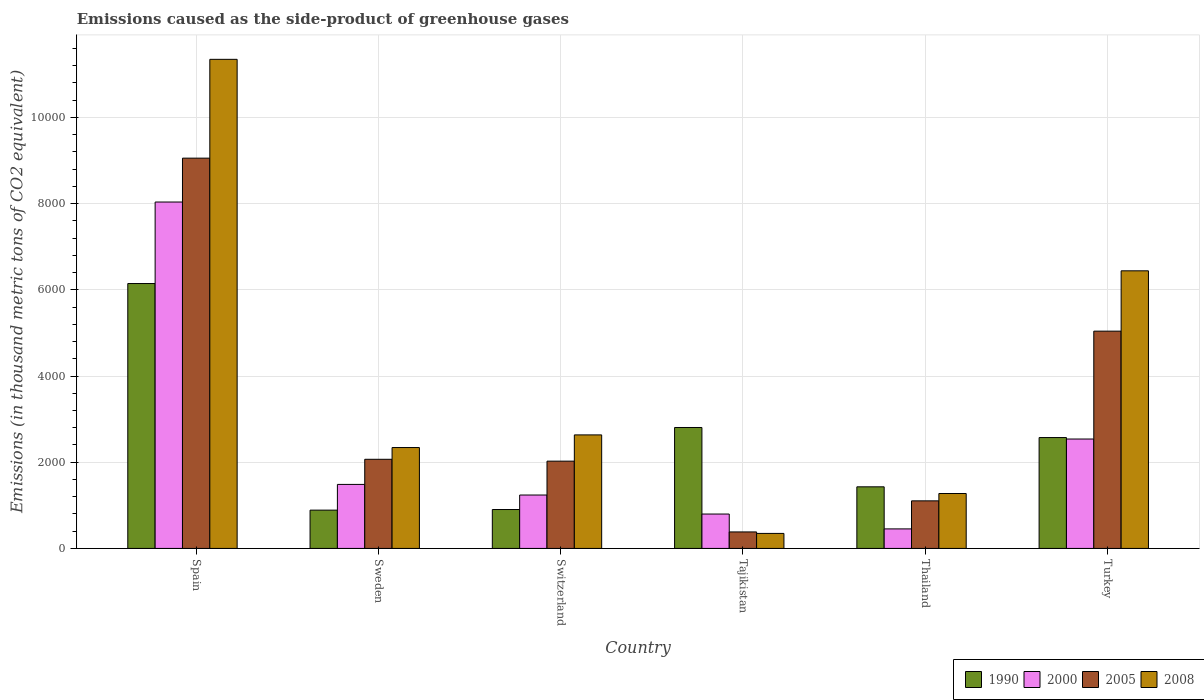Are the number of bars per tick equal to the number of legend labels?
Provide a short and direct response. Yes. Are the number of bars on each tick of the X-axis equal?
Your answer should be very brief. Yes. How many bars are there on the 3rd tick from the left?
Ensure brevity in your answer.  4. How many bars are there on the 4th tick from the right?
Offer a very short reply. 4. What is the label of the 1st group of bars from the left?
Give a very brief answer. Spain. What is the emissions caused as the side-product of greenhouse gases in 2000 in Tajikistan?
Provide a short and direct response. 798. Across all countries, what is the maximum emissions caused as the side-product of greenhouse gases in 2005?
Give a very brief answer. 9055.1. Across all countries, what is the minimum emissions caused as the side-product of greenhouse gases in 2008?
Keep it short and to the point. 348.3. In which country was the emissions caused as the side-product of greenhouse gases in 2008 minimum?
Ensure brevity in your answer.  Tajikistan. What is the total emissions caused as the side-product of greenhouse gases in 2008 in the graph?
Provide a succinct answer. 2.44e+04. What is the difference between the emissions caused as the side-product of greenhouse gases in 2008 in Thailand and that in Turkey?
Offer a terse response. -5166.5. What is the difference between the emissions caused as the side-product of greenhouse gases in 1990 in Switzerland and the emissions caused as the side-product of greenhouse gases in 2005 in Tajikistan?
Your answer should be compact. 519.6. What is the average emissions caused as the side-product of greenhouse gases in 2008 per country?
Provide a short and direct response. 4064.43. What is the difference between the emissions caused as the side-product of greenhouse gases of/in 2000 and emissions caused as the side-product of greenhouse gases of/in 2008 in Switzerland?
Provide a succinct answer. -1394.9. What is the ratio of the emissions caused as the side-product of greenhouse gases in 1990 in Sweden to that in Thailand?
Offer a terse response. 0.62. Is the emissions caused as the side-product of greenhouse gases in 2000 in Spain less than that in Tajikistan?
Ensure brevity in your answer.  No. Is the difference between the emissions caused as the side-product of greenhouse gases in 2000 in Tajikistan and Thailand greater than the difference between the emissions caused as the side-product of greenhouse gases in 2008 in Tajikistan and Thailand?
Ensure brevity in your answer.  Yes. What is the difference between the highest and the second highest emissions caused as the side-product of greenhouse gases in 2000?
Offer a terse response. -1053.2. What is the difference between the highest and the lowest emissions caused as the side-product of greenhouse gases in 2005?
Your answer should be very brief. 8672.1. In how many countries, is the emissions caused as the side-product of greenhouse gases in 2005 greater than the average emissions caused as the side-product of greenhouse gases in 2005 taken over all countries?
Make the answer very short. 2. Is the sum of the emissions caused as the side-product of greenhouse gases in 2008 in Switzerland and Tajikistan greater than the maximum emissions caused as the side-product of greenhouse gases in 2000 across all countries?
Keep it short and to the point. No. Is it the case that in every country, the sum of the emissions caused as the side-product of greenhouse gases in 2005 and emissions caused as the side-product of greenhouse gases in 1990 is greater than the sum of emissions caused as the side-product of greenhouse gases in 2008 and emissions caused as the side-product of greenhouse gases in 2000?
Your response must be concise. Yes. What does the 1st bar from the left in Tajikistan represents?
Give a very brief answer. 1990. What does the 4th bar from the right in Switzerland represents?
Your answer should be very brief. 1990. How many bars are there?
Your response must be concise. 24. Are all the bars in the graph horizontal?
Provide a short and direct response. No. Are the values on the major ticks of Y-axis written in scientific E-notation?
Offer a very short reply. No. Does the graph contain any zero values?
Provide a short and direct response. No. How many legend labels are there?
Your answer should be very brief. 4. How are the legend labels stacked?
Provide a short and direct response. Horizontal. What is the title of the graph?
Ensure brevity in your answer.  Emissions caused as the side-product of greenhouse gases. Does "1992" appear as one of the legend labels in the graph?
Your answer should be compact. No. What is the label or title of the X-axis?
Your response must be concise. Country. What is the label or title of the Y-axis?
Your answer should be compact. Emissions (in thousand metric tons of CO2 equivalent). What is the Emissions (in thousand metric tons of CO2 equivalent) of 1990 in Spain?
Offer a very short reply. 6146. What is the Emissions (in thousand metric tons of CO2 equivalent) in 2000 in Spain?
Make the answer very short. 8037.1. What is the Emissions (in thousand metric tons of CO2 equivalent) in 2005 in Spain?
Offer a terse response. 9055.1. What is the Emissions (in thousand metric tons of CO2 equivalent) in 2008 in Spain?
Give a very brief answer. 1.13e+04. What is the Emissions (in thousand metric tons of CO2 equivalent) in 1990 in Sweden?
Offer a terse response. 888.6. What is the Emissions (in thousand metric tons of CO2 equivalent) in 2000 in Sweden?
Ensure brevity in your answer.  1485.3. What is the Emissions (in thousand metric tons of CO2 equivalent) in 2005 in Sweden?
Your answer should be compact. 2068.4. What is the Emissions (in thousand metric tons of CO2 equivalent) in 2008 in Sweden?
Make the answer very short. 2340.9. What is the Emissions (in thousand metric tons of CO2 equivalent) of 1990 in Switzerland?
Provide a succinct answer. 902.6. What is the Emissions (in thousand metric tons of CO2 equivalent) in 2000 in Switzerland?
Keep it short and to the point. 1239.2. What is the Emissions (in thousand metric tons of CO2 equivalent) of 2005 in Switzerland?
Your answer should be compact. 2025. What is the Emissions (in thousand metric tons of CO2 equivalent) of 2008 in Switzerland?
Offer a very short reply. 2634.1. What is the Emissions (in thousand metric tons of CO2 equivalent) in 1990 in Tajikistan?
Keep it short and to the point. 2806.1. What is the Emissions (in thousand metric tons of CO2 equivalent) of 2000 in Tajikistan?
Your response must be concise. 798. What is the Emissions (in thousand metric tons of CO2 equivalent) in 2005 in Tajikistan?
Provide a succinct answer. 383. What is the Emissions (in thousand metric tons of CO2 equivalent) of 2008 in Tajikistan?
Offer a very short reply. 348.3. What is the Emissions (in thousand metric tons of CO2 equivalent) of 1990 in Thailand?
Provide a succinct answer. 1429.5. What is the Emissions (in thousand metric tons of CO2 equivalent) of 2000 in Thailand?
Give a very brief answer. 453.1. What is the Emissions (in thousand metric tons of CO2 equivalent) of 2005 in Thailand?
Provide a short and direct response. 1103.9. What is the Emissions (in thousand metric tons of CO2 equivalent) in 2008 in Thailand?
Make the answer very short. 1274.5. What is the Emissions (in thousand metric tons of CO2 equivalent) in 1990 in Turkey?
Keep it short and to the point. 2572.7. What is the Emissions (in thousand metric tons of CO2 equivalent) of 2000 in Turkey?
Your answer should be very brief. 2538.5. What is the Emissions (in thousand metric tons of CO2 equivalent) of 2005 in Turkey?
Your answer should be very brief. 5041.3. What is the Emissions (in thousand metric tons of CO2 equivalent) in 2008 in Turkey?
Provide a short and direct response. 6441. Across all countries, what is the maximum Emissions (in thousand metric tons of CO2 equivalent) of 1990?
Offer a very short reply. 6146. Across all countries, what is the maximum Emissions (in thousand metric tons of CO2 equivalent) of 2000?
Offer a terse response. 8037.1. Across all countries, what is the maximum Emissions (in thousand metric tons of CO2 equivalent) in 2005?
Give a very brief answer. 9055.1. Across all countries, what is the maximum Emissions (in thousand metric tons of CO2 equivalent) of 2008?
Provide a short and direct response. 1.13e+04. Across all countries, what is the minimum Emissions (in thousand metric tons of CO2 equivalent) of 1990?
Offer a terse response. 888.6. Across all countries, what is the minimum Emissions (in thousand metric tons of CO2 equivalent) of 2000?
Give a very brief answer. 453.1. Across all countries, what is the minimum Emissions (in thousand metric tons of CO2 equivalent) of 2005?
Ensure brevity in your answer.  383. Across all countries, what is the minimum Emissions (in thousand metric tons of CO2 equivalent) of 2008?
Offer a terse response. 348.3. What is the total Emissions (in thousand metric tons of CO2 equivalent) in 1990 in the graph?
Provide a succinct answer. 1.47e+04. What is the total Emissions (in thousand metric tons of CO2 equivalent) in 2000 in the graph?
Ensure brevity in your answer.  1.46e+04. What is the total Emissions (in thousand metric tons of CO2 equivalent) in 2005 in the graph?
Provide a short and direct response. 1.97e+04. What is the total Emissions (in thousand metric tons of CO2 equivalent) in 2008 in the graph?
Your answer should be compact. 2.44e+04. What is the difference between the Emissions (in thousand metric tons of CO2 equivalent) of 1990 in Spain and that in Sweden?
Give a very brief answer. 5257.4. What is the difference between the Emissions (in thousand metric tons of CO2 equivalent) of 2000 in Spain and that in Sweden?
Your response must be concise. 6551.8. What is the difference between the Emissions (in thousand metric tons of CO2 equivalent) of 2005 in Spain and that in Sweden?
Provide a succinct answer. 6986.7. What is the difference between the Emissions (in thousand metric tons of CO2 equivalent) of 2008 in Spain and that in Sweden?
Provide a succinct answer. 9006.9. What is the difference between the Emissions (in thousand metric tons of CO2 equivalent) in 1990 in Spain and that in Switzerland?
Keep it short and to the point. 5243.4. What is the difference between the Emissions (in thousand metric tons of CO2 equivalent) of 2000 in Spain and that in Switzerland?
Give a very brief answer. 6797.9. What is the difference between the Emissions (in thousand metric tons of CO2 equivalent) of 2005 in Spain and that in Switzerland?
Make the answer very short. 7030.1. What is the difference between the Emissions (in thousand metric tons of CO2 equivalent) of 2008 in Spain and that in Switzerland?
Make the answer very short. 8713.7. What is the difference between the Emissions (in thousand metric tons of CO2 equivalent) in 1990 in Spain and that in Tajikistan?
Your answer should be very brief. 3339.9. What is the difference between the Emissions (in thousand metric tons of CO2 equivalent) of 2000 in Spain and that in Tajikistan?
Offer a very short reply. 7239.1. What is the difference between the Emissions (in thousand metric tons of CO2 equivalent) in 2005 in Spain and that in Tajikistan?
Make the answer very short. 8672.1. What is the difference between the Emissions (in thousand metric tons of CO2 equivalent) in 2008 in Spain and that in Tajikistan?
Offer a very short reply. 1.10e+04. What is the difference between the Emissions (in thousand metric tons of CO2 equivalent) of 1990 in Spain and that in Thailand?
Offer a terse response. 4716.5. What is the difference between the Emissions (in thousand metric tons of CO2 equivalent) in 2000 in Spain and that in Thailand?
Offer a very short reply. 7584. What is the difference between the Emissions (in thousand metric tons of CO2 equivalent) of 2005 in Spain and that in Thailand?
Your answer should be very brief. 7951.2. What is the difference between the Emissions (in thousand metric tons of CO2 equivalent) of 2008 in Spain and that in Thailand?
Offer a very short reply. 1.01e+04. What is the difference between the Emissions (in thousand metric tons of CO2 equivalent) in 1990 in Spain and that in Turkey?
Provide a succinct answer. 3573.3. What is the difference between the Emissions (in thousand metric tons of CO2 equivalent) of 2000 in Spain and that in Turkey?
Your response must be concise. 5498.6. What is the difference between the Emissions (in thousand metric tons of CO2 equivalent) of 2005 in Spain and that in Turkey?
Offer a terse response. 4013.8. What is the difference between the Emissions (in thousand metric tons of CO2 equivalent) in 2008 in Spain and that in Turkey?
Provide a succinct answer. 4906.8. What is the difference between the Emissions (in thousand metric tons of CO2 equivalent) of 1990 in Sweden and that in Switzerland?
Offer a terse response. -14. What is the difference between the Emissions (in thousand metric tons of CO2 equivalent) in 2000 in Sweden and that in Switzerland?
Offer a terse response. 246.1. What is the difference between the Emissions (in thousand metric tons of CO2 equivalent) of 2005 in Sweden and that in Switzerland?
Offer a very short reply. 43.4. What is the difference between the Emissions (in thousand metric tons of CO2 equivalent) of 2008 in Sweden and that in Switzerland?
Provide a succinct answer. -293.2. What is the difference between the Emissions (in thousand metric tons of CO2 equivalent) in 1990 in Sweden and that in Tajikistan?
Offer a terse response. -1917.5. What is the difference between the Emissions (in thousand metric tons of CO2 equivalent) of 2000 in Sweden and that in Tajikistan?
Offer a very short reply. 687.3. What is the difference between the Emissions (in thousand metric tons of CO2 equivalent) of 2005 in Sweden and that in Tajikistan?
Your response must be concise. 1685.4. What is the difference between the Emissions (in thousand metric tons of CO2 equivalent) of 2008 in Sweden and that in Tajikistan?
Give a very brief answer. 1992.6. What is the difference between the Emissions (in thousand metric tons of CO2 equivalent) in 1990 in Sweden and that in Thailand?
Offer a terse response. -540.9. What is the difference between the Emissions (in thousand metric tons of CO2 equivalent) in 2000 in Sweden and that in Thailand?
Offer a terse response. 1032.2. What is the difference between the Emissions (in thousand metric tons of CO2 equivalent) of 2005 in Sweden and that in Thailand?
Give a very brief answer. 964.5. What is the difference between the Emissions (in thousand metric tons of CO2 equivalent) of 2008 in Sweden and that in Thailand?
Keep it short and to the point. 1066.4. What is the difference between the Emissions (in thousand metric tons of CO2 equivalent) in 1990 in Sweden and that in Turkey?
Ensure brevity in your answer.  -1684.1. What is the difference between the Emissions (in thousand metric tons of CO2 equivalent) of 2000 in Sweden and that in Turkey?
Offer a very short reply. -1053.2. What is the difference between the Emissions (in thousand metric tons of CO2 equivalent) of 2005 in Sweden and that in Turkey?
Give a very brief answer. -2972.9. What is the difference between the Emissions (in thousand metric tons of CO2 equivalent) in 2008 in Sweden and that in Turkey?
Your answer should be very brief. -4100.1. What is the difference between the Emissions (in thousand metric tons of CO2 equivalent) in 1990 in Switzerland and that in Tajikistan?
Provide a succinct answer. -1903.5. What is the difference between the Emissions (in thousand metric tons of CO2 equivalent) in 2000 in Switzerland and that in Tajikistan?
Provide a short and direct response. 441.2. What is the difference between the Emissions (in thousand metric tons of CO2 equivalent) in 2005 in Switzerland and that in Tajikistan?
Your answer should be very brief. 1642. What is the difference between the Emissions (in thousand metric tons of CO2 equivalent) of 2008 in Switzerland and that in Tajikistan?
Keep it short and to the point. 2285.8. What is the difference between the Emissions (in thousand metric tons of CO2 equivalent) of 1990 in Switzerland and that in Thailand?
Keep it short and to the point. -526.9. What is the difference between the Emissions (in thousand metric tons of CO2 equivalent) of 2000 in Switzerland and that in Thailand?
Make the answer very short. 786.1. What is the difference between the Emissions (in thousand metric tons of CO2 equivalent) in 2005 in Switzerland and that in Thailand?
Provide a succinct answer. 921.1. What is the difference between the Emissions (in thousand metric tons of CO2 equivalent) of 2008 in Switzerland and that in Thailand?
Ensure brevity in your answer.  1359.6. What is the difference between the Emissions (in thousand metric tons of CO2 equivalent) of 1990 in Switzerland and that in Turkey?
Give a very brief answer. -1670.1. What is the difference between the Emissions (in thousand metric tons of CO2 equivalent) in 2000 in Switzerland and that in Turkey?
Provide a short and direct response. -1299.3. What is the difference between the Emissions (in thousand metric tons of CO2 equivalent) of 2005 in Switzerland and that in Turkey?
Provide a succinct answer. -3016.3. What is the difference between the Emissions (in thousand metric tons of CO2 equivalent) in 2008 in Switzerland and that in Turkey?
Your answer should be compact. -3806.9. What is the difference between the Emissions (in thousand metric tons of CO2 equivalent) of 1990 in Tajikistan and that in Thailand?
Your answer should be very brief. 1376.6. What is the difference between the Emissions (in thousand metric tons of CO2 equivalent) in 2000 in Tajikistan and that in Thailand?
Your answer should be very brief. 344.9. What is the difference between the Emissions (in thousand metric tons of CO2 equivalent) in 2005 in Tajikistan and that in Thailand?
Ensure brevity in your answer.  -720.9. What is the difference between the Emissions (in thousand metric tons of CO2 equivalent) of 2008 in Tajikistan and that in Thailand?
Provide a short and direct response. -926.2. What is the difference between the Emissions (in thousand metric tons of CO2 equivalent) in 1990 in Tajikistan and that in Turkey?
Offer a terse response. 233.4. What is the difference between the Emissions (in thousand metric tons of CO2 equivalent) in 2000 in Tajikistan and that in Turkey?
Offer a terse response. -1740.5. What is the difference between the Emissions (in thousand metric tons of CO2 equivalent) in 2005 in Tajikistan and that in Turkey?
Make the answer very short. -4658.3. What is the difference between the Emissions (in thousand metric tons of CO2 equivalent) in 2008 in Tajikistan and that in Turkey?
Make the answer very short. -6092.7. What is the difference between the Emissions (in thousand metric tons of CO2 equivalent) in 1990 in Thailand and that in Turkey?
Your answer should be compact. -1143.2. What is the difference between the Emissions (in thousand metric tons of CO2 equivalent) of 2000 in Thailand and that in Turkey?
Your response must be concise. -2085.4. What is the difference between the Emissions (in thousand metric tons of CO2 equivalent) in 2005 in Thailand and that in Turkey?
Provide a succinct answer. -3937.4. What is the difference between the Emissions (in thousand metric tons of CO2 equivalent) of 2008 in Thailand and that in Turkey?
Provide a succinct answer. -5166.5. What is the difference between the Emissions (in thousand metric tons of CO2 equivalent) in 1990 in Spain and the Emissions (in thousand metric tons of CO2 equivalent) in 2000 in Sweden?
Your answer should be very brief. 4660.7. What is the difference between the Emissions (in thousand metric tons of CO2 equivalent) in 1990 in Spain and the Emissions (in thousand metric tons of CO2 equivalent) in 2005 in Sweden?
Make the answer very short. 4077.6. What is the difference between the Emissions (in thousand metric tons of CO2 equivalent) of 1990 in Spain and the Emissions (in thousand metric tons of CO2 equivalent) of 2008 in Sweden?
Make the answer very short. 3805.1. What is the difference between the Emissions (in thousand metric tons of CO2 equivalent) of 2000 in Spain and the Emissions (in thousand metric tons of CO2 equivalent) of 2005 in Sweden?
Provide a succinct answer. 5968.7. What is the difference between the Emissions (in thousand metric tons of CO2 equivalent) of 2000 in Spain and the Emissions (in thousand metric tons of CO2 equivalent) of 2008 in Sweden?
Provide a succinct answer. 5696.2. What is the difference between the Emissions (in thousand metric tons of CO2 equivalent) in 2005 in Spain and the Emissions (in thousand metric tons of CO2 equivalent) in 2008 in Sweden?
Ensure brevity in your answer.  6714.2. What is the difference between the Emissions (in thousand metric tons of CO2 equivalent) of 1990 in Spain and the Emissions (in thousand metric tons of CO2 equivalent) of 2000 in Switzerland?
Ensure brevity in your answer.  4906.8. What is the difference between the Emissions (in thousand metric tons of CO2 equivalent) in 1990 in Spain and the Emissions (in thousand metric tons of CO2 equivalent) in 2005 in Switzerland?
Keep it short and to the point. 4121. What is the difference between the Emissions (in thousand metric tons of CO2 equivalent) of 1990 in Spain and the Emissions (in thousand metric tons of CO2 equivalent) of 2008 in Switzerland?
Your answer should be very brief. 3511.9. What is the difference between the Emissions (in thousand metric tons of CO2 equivalent) in 2000 in Spain and the Emissions (in thousand metric tons of CO2 equivalent) in 2005 in Switzerland?
Give a very brief answer. 6012.1. What is the difference between the Emissions (in thousand metric tons of CO2 equivalent) in 2000 in Spain and the Emissions (in thousand metric tons of CO2 equivalent) in 2008 in Switzerland?
Your answer should be very brief. 5403. What is the difference between the Emissions (in thousand metric tons of CO2 equivalent) of 2005 in Spain and the Emissions (in thousand metric tons of CO2 equivalent) of 2008 in Switzerland?
Provide a short and direct response. 6421. What is the difference between the Emissions (in thousand metric tons of CO2 equivalent) in 1990 in Spain and the Emissions (in thousand metric tons of CO2 equivalent) in 2000 in Tajikistan?
Ensure brevity in your answer.  5348. What is the difference between the Emissions (in thousand metric tons of CO2 equivalent) in 1990 in Spain and the Emissions (in thousand metric tons of CO2 equivalent) in 2005 in Tajikistan?
Your answer should be compact. 5763. What is the difference between the Emissions (in thousand metric tons of CO2 equivalent) of 1990 in Spain and the Emissions (in thousand metric tons of CO2 equivalent) of 2008 in Tajikistan?
Offer a terse response. 5797.7. What is the difference between the Emissions (in thousand metric tons of CO2 equivalent) of 2000 in Spain and the Emissions (in thousand metric tons of CO2 equivalent) of 2005 in Tajikistan?
Ensure brevity in your answer.  7654.1. What is the difference between the Emissions (in thousand metric tons of CO2 equivalent) of 2000 in Spain and the Emissions (in thousand metric tons of CO2 equivalent) of 2008 in Tajikistan?
Your response must be concise. 7688.8. What is the difference between the Emissions (in thousand metric tons of CO2 equivalent) in 2005 in Spain and the Emissions (in thousand metric tons of CO2 equivalent) in 2008 in Tajikistan?
Give a very brief answer. 8706.8. What is the difference between the Emissions (in thousand metric tons of CO2 equivalent) of 1990 in Spain and the Emissions (in thousand metric tons of CO2 equivalent) of 2000 in Thailand?
Keep it short and to the point. 5692.9. What is the difference between the Emissions (in thousand metric tons of CO2 equivalent) in 1990 in Spain and the Emissions (in thousand metric tons of CO2 equivalent) in 2005 in Thailand?
Provide a succinct answer. 5042.1. What is the difference between the Emissions (in thousand metric tons of CO2 equivalent) in 1990 in Spain and the Emissions (in thousand metric tons of CO2 equivalent) in 2008 in Thailand?
Keep it short and to the point. 4871.5. What is the difference between the Emissions (in thousand metric tons of CO2 equivalent) of 2000 in Spain and the Emissions (in thousand metric tons of CO2 equivalent) of 2005 in Thailand?
Your response must be concise. 6933.2. What is the difference between the Emissions (in thousand metric tons of CO2 equivalent) in 2000 in Spain and the Emissions (in thousand metric tons of CO2 equivalent) in 2008 in Thailand?
Offer a very short reply. 6762.6. What is the difference between the Emissions (in thousand metric tons of CO2 equivalent) in 2005 in Spain and the Emissions (in thousand metric tons of CO2 equivalent) in 2008 in Thailand?
Offer a terse response. 7780.6. What is the difference between the Emissions (in thousand metric tons of CO2 equivalent) of 1990 in Spain and the Emissions (in thousand metric tons of CO2 equivalent) of 2000 in Turkey?
Your answer should be compact. 3607.5. What is the difference between the Emissions (in thousand metric tons of CO2 equivalent) in 1990 in Spain and the Emissions (in thousand metric tons of CO2 equivalent) in 2005 in Turkey?
Ensure brevity in your answer.  1104.7. What is the difference between the Emissions (in thousand metric tons of CO2 equivalent) of 1990 in Spain and the Emissions (in thousand metric tons of CO2 equivalent) of 2008 in Turkey?
Keep it short and to the point. -295. What is the difference between the Emissions (in thousand metric tons of CO2 equivalent) in 2000 in Spain and the Emissions (in thousand metric tons of CO2 equivalent) in 2005 in Turkey?
Offer a very short reply. 2995.8. What is the difference between the Emissions (in thousand metric tons of CO2 equivalent) of 2000 in Spain and the Emissions (in thousand metric tons of CO2 equivalent) of 2008 in Turkey?
Ensure brevity in your answer.  1596.1. What is the difference between the Emissions (in thousand metric tons of CO2 equivalent) in 2005 in Spain and the Emissions (in thousand metric tons of CO2 equivalent) in 2008 in Turkey?
Your answer should be compact. 2614.1. What is the difference between the Emissions (in thousand metric tons of CO2 equivalent) in 1990 in Sweden and the Emissions (in thousand metric tons of CO2 equivalent) in 2000 in Switzerland?
Your answer should be very brief. -350.6. What is the difference between the Emissions (in thousand metric tons of CO2 equivalent) of 1990 in Sweden and the Emissions (in thousand metric tons of CO2 equivalent) of 2005 in Switzerland?
Your answer should be very brief. -1136.4. What is the difference between the Emissions (in thousand metric tons of CO2 equivalent) in 1990 in Sweden and the Emissions (in thousand metric tons of CO2 equivalent) in 2008 in Switzerland?
Ensure brevity in your answer.  -1745.5. What is the difference between the Emissions (in thousand metric tons of CO2 equivalent) in 2000 in Sweden and the Emissions (in thousand metric tons of CO2 equivalent) in 2005 in Switzerland?
Ensure brevity in your answer.  -539.7. What is the difference between the Emissions (in thousand metric tons of CO2 equivalent) of 2000 in Sweden and the Emissions (in thousand metric tons of CO2 equivalent) of 2008 in Switzerland?
Offer a terse response. -1148.8. What is the difference between the Emissions (in thousand metric tons of CO2 equivalent) of 2005 in Sweden and the Emissions (in thousand metric tons of CO2 equivalent) of 2008 in Switzerland?
Ensure brevity in your answer.  -565.7. What is the difference between the Emissions (in thousand metric tons of CO2 equivalent) in 1990 in Sweden and the Emissions (in thousand metric tons of CO2 equivalent) in 2000 in Tajikistan?
Your answer should be very brief. 90.6. What is the difference between the Emissions (in thousand metric tons of CO2 equivalent) in 1990 in Sweden and the Emissions (in thousand metric tons of CO2 equivalent) in 2005 in Tajikistan?
Keep it short and to the point. 505.6. What is the difference between the Emissions (in thousand metric tons of CO2 equivalent) in 1990 in Sweden and the Emissions (in thousand metric tons of CO2 equivalent) in 2008 in Tajikistan?
Give a very brief answer. 540.3. What is the difference between the Emissions (in thousand metric tons of CO2 equivalent) of 2000 in Sweden and the Emissions (in thousand metric tons of CO2 equivalent) of 2005 in Tajikistan?
Keep it short and to the point. 1102.3. What is the difference between the Emissions (in thousand metric tons of CO2 equivalent) in 2000 in Sweden and the Emissions (in thousand metric tons of CO2 equivalent) in 2008 in Tajikistan?
Your answer should be very brief. 1137. What is the difference between the Emissions (in thousand metric tons of CO2 equivalent) of 2005 in Sweden and the Emissions (in thousand metric tons of CO2 equivalent) of 2008 in Tajikistan?
Your answer should be very brief. 1720.1. What is the difference between the Emissions (in thousand metric tons of CO2 equivalent) in 1990 in Sweden and the Emissions (in thousand metric tons of CO2 equivalent) in 2000 in Thailand?
Your response must be concise. 435.5. What is the difference between the Emissions (in thousand metric tons of CO2 equivalent) in 1990 in Sweden and the Emissions (in thousand metric tons of CO2 equivalent) in 2005 in Thailand?
Keep it short and to the point. -215.3. What is the difference between the Emissions (in thousand metric tons of CO2 equivalent) of 1990 in Sweden and the Emissions (in thousand metric tons of CO2 equivalent) of 2008 in Thailand?
Provide a short and direct response. -385.9. What is the difference between the Emissions (in thousand metric tons of CO2 equivalent) of 2000 in Sweden and the Emissions (in thousand metric tons of CO2 equivalent) of 2005 in Thailand?
Give a very brief answer. 381.4. What is the difference between the Emissions (in thousand metric tons of CO2 equivalent) of 2000 in Sweden and the Emissions (in thousand metric tons of CO2 equivalent) of 2008 in Thailand?
Your answer should be compact. 210.8. What is the difference between the Emissions (in thousand metric tons of CO2 equivalent) of 2005 in Sweden and the Emissions (in thousand metric tons of CO2 equivalent) of 2008 in Thailand?
Your answer should be compact. 793.9. What is the difference between the Emissions (in thousand metric tons of CO2 equivalent) in 1990 in Sweden and the Emissions (in thousand metric tons of CO2 equivalent) in 2000 in Turkey?
Offer a very short reply. -1649.9. What is the difference between the Emissions (in thousand metric tons of CO2 equivalent) in 1990 in Sweden and the Emissions (in thousand metric tons of CO2 equivalent) in 2005 in Turkey?
Offer a terse response. -4152.7. What is the difference between the Emissions (in thousand metric tons of CO2 equivalent) in 1990 in Sweden and the Emissions (in thousand metric tons of CO2 equivalent) in 2008 in Turkey?
Provide a succinct answer. -5552.4. What is the difference between the Emissions (in thousand metric tons of CO2 equivalent) in 2000 in Sweden and the Emissions (in thousand metric tons of CO2 equivalent) in 2005 in Turkey?
Make the answer very short. -3556. What is the difference between the Emissions (in thousand metric tons of CO2 equivalent) of 2000 in Sweden and the Emissions (in thousand metric tons of CO2 equivalent) of 2008 in Turkey?
Give a very brief answer. -4955.7. What is the difference between the Emissions (in thousand metric tons of CO2 equivalent) in 2005 in Sweden and the Emissions (in thousand metric tons of CO2 equivalent) in 2008 in Turkey?
Your response must be concise. -4372.6. What is the difference between the Emissions (in thousand metric tons of CO2 equivalent) of 1990 in Switzerland and the Emissions (in thousand metric tons of CO2 equivalent) of 2000 in Tajikistan?
Give a very brief answer. 104.6. What is the difference between the Emissions (in thousand metric tons of CO2 equivalent) of 1990 in Switzerland and the Emissions (in thousand metric tons of CO2 equivalent) of 2005 in Tajikistan?
Ensure brevity in your answer.  519.6. What is the difference between the Emissions (in thousand metric tons of CO2 equivalent) of 1990 in Switzerland and the Emissions (in thousand metric tons of CO2 equivalent) of 2008 in Tajikistan?
Provide a short and direct response. 554.3. What is the difference between the Emissions (in thousand metric tons of CO2 equivalent) in 2000 in Switzerland and the Emissions (in thousand metric tons of CO2 equivalent) in 2005 in Tajikistan?
Your answer should be very brief. 856.2. What is the difference between the Emissions (in thousand metric tons of CO2 equivalent) of 2000 in Switzerland and the Emissions (in thousand metric tons of CO2 equivalent) of 2008 in Tajikistan?
Your answer should be compact. 890.9. What is the difference between the Emissions (in thousand metric tons of CO2 equivalent) of 2005 in Switzerland and the Emissions (in thousand metric tons of CO2 equivalent) of 2008 in Tajikistan?
Your response must be concise. 1676.7. What is the difference between the Emissions (in thousand metric tons of CO2 equivalent) of 1990 in Switzerland and the Emissions (in thousand metric tons of CO2 equivalent) of 2000 in Thailand?
Offer a terse response. 449.5. What is the difference between the Emissions (in thousand metric tons of CO2 equivalent) of 1990 in Switzerland and the Emissions (in thousand metric tons of CO2 equivalent) of 2005 in Thailand?
Provide a succinct answer. -201.3. What is the difference between the Emissions (in thousand metric tons of CO2 equivalent) of 1990 in Switzerland and the Emissions (in thousand metric tons of CO2 equivalent) of 2008 in Thailand?
Provide a short and direct response. -371.9. What is the difference between the Emissions (in thousand metric tons of CO2 equivalent) of 2000 in Switzerland and the Emissions (in thousand metric tons of CO2 equivalent) of 2005 in Thailand?
Provide a succinct answer. 135.3. What is the difference between the Emissions (in thousand metric tons of CO2 equivalent) in 2000 in Switzerland and the Emissions (in thousand metric tons of CO2 equivalent) in 2008 in Thailand?
Your response must be concise. -35.3. What is the difference between the Emissions (in thousand metric tons of CO2 equivalent) of 2005 in Switzerland and the Emissions (in thousand metric tons of CO2 equivalent) of 2008 in Thailand?
Provide a short and direct response. 750.5. What is the difference between the Emissions (in thousand metric tons of CO2 equivalent) in 1990 in Switzerland and the Emissions (in thousand metric tons of CO2 equivalent) in 2000 in Turkey?
Keep it short and to the point. -1635.9. What is the difference between the Emissions (in thousand metric tons of CO2 equivalent) in 1990 in Switzerland and the Emissions (in thousand metric tons of CO2 equivalent) in 2005 in Turkey?
Ensure brevity in your answer.  -4138.7. What is the difference between the Emissions (in thousand metric tons of CO2 equivalent) of 1990 in Switzerland and the Emissions (in thousand metric tons of CO2 equivalent) of 2008 in Turkey?
Provide a short and direct response. -5538.4. What is the difference between the Emissions (in thousand metric tons of CO2 equivalent) of 2000 in Switzerland and the Emissions (in thousand metric tons of CO2 equivalent) of 2005 in Turkey?
Offer a terse response. -3802.1. What is the difference between the Emissions (in thousand metric tons of CO2 equivalent) of 2000 in Switzerland and the Emissions (in thousand metric tons of CO2 equivalent) of 2008 in Turkey?
Provide a succinct answer. -5201.8. What is the difference between the Emissions (in thousand metric tons of CO2 equivalent) of 2005 in Switzerland and the Emissions (in thousand metric tons of CO2 equivalent) of 2008 in Turkey?
Your answer should be very brief. -4416. What is the difference between the Emissions (in thousand metric tons of CO2 equivalent) in 1990 in Tajikistan and the Emissions (in thousand metric tons of CO2 equivalent) in 2000 in Thailand?
Offer a very short reply. 2353. What is the difference between the Emissions (in thousand metric tons of CO2 equivalent) in 1990 in Tajikistan and the Emissions (in thousand metric tons of CO2 equivalent) in 2005 in Thailand?
Ensure brevity in your answer.  1702.2. What is the difference between the Emissions (in thousand metric tons of CO2 equivalent) of 1990 in Tajikistan and the Emissions (in thousand metric tons of CO2 equivalent) of 2008 in Thailand?
Make the answer very short. 1531.6. What is the difference between the Emissions (in thousand metric tons of CO2 equivalent) of 2000 in Tajikistan and the Emissions (in thousand metric tons of CO2 equivalent) of 2005 in Thailand?
Provide a short and direct response. -305.9. What is the difference between the Emissions (in thousand metric tons of CO2 equivalent) in 2000 in Tajikistan and the Emissions (in thousand metric tons of CO2 equivalent) in 2008 in Thailand?
Your response must be concise. -476.5. What is the difference between the Emissions (in thousand metric tons of CO2 equivalent) of 2005 in Tajikistan and the Emissions (in thousand metric tons of CO2 equivalent) of 2008 in Thailand?
Offer a terse response. -891.5. What is the difference between the Emissions (in thousand metric tons of CO2 equivalent) of 1990 in Tajikistan and the Emissions (in thousand metric tons of CO2 equivalent) of 2000 in Turkey?
Provide a short and direct response. 267.6. What is the difference between the Emissions (in thousand metric tons of CO2 equivalent) in 1990 in Tajikistan and the Emissions (in thousand metric tons of CO2 equivalent) in 2005 in Turkey?
Provide a short and direct response. -2235.2. What is the difference between the Emissions (in thousand metric tons of CO2 equivalent) of 1990 in Tajikistan and the Emissions (in thousand metric tons of CO2 equivalent) of 2008 in Turkey?
Ensure brevity in your answer.  -3634.9. What is the difference between the Emissions (in thousand metric tons of CO2 equivalent) of 2000 in Tajikistan and the Emissions (in thousand metric tons of CO2 equivalent) of 2005 in Turkey?
Give a very brief answer. -4243.3. What is the difference between the Emissions (in thousand metric tons of CO2 equivalent) in 2000 in Tajikistan and the Emissions (in thousand metric tons of CO2 equivalent) in 2008 in Turkey?
Your answer should be very brief. -5643. What is the difference between the Emissions (in thousand metric tons of CO2 equivalent) of 2005 in Tajikistan and the Emissions (in thousand metric tons of CO2 equivalent) of 2008 in Turkey?
Give a very brief answer. -6058. What is the difference between the Emissions (in thousand metric tons of CO2 equivalent) in 1990 in Thailand and the Emissions (in thousand metric tons of CO2 equivalent) in 2000 in Turkey?
Your response must be concise. -1109. What is the difference between the Emissions (in thousand metric tons of CO2 equivalent) of 1990 in Thailand and the Emissions (in thousand metric tons of CO2 equivalent) of 2005 in Turkey?
Offer a terse response. -3611.8. What is the difference between the Emissions (in thousand metric tons of CO2 equivalent) of 1990 in Thailand and the Emissions (in thousand metric tons of CO2 equivalent) of 2008 in Turkey?
Provide a short and direct response. -5011.5. What is the difference between the Emissions (in thousand metric tons of CO2 equivalent) of 2000 in Thailand and the Emissions (in thousand metric tons of CO2 equivalent) of 2005 in Turkey?
Offer a very short reply. -4588.2. What is the difference between the Emissions (in thousand metric tons of CO2 equivalent) of 2000 in Thailand and the Emissions (in thousand metric tons of CO2 equivalent) of 2008 in Turkey?
Provide a short and direct response. -5987.9. What is the difference between the Emissions (in thousand metric tons of CO2 equivalent) in 2005 in Thailand and the Emissions (in thousand metric tons of CO2 equivalent) in 2008 in Turkey?
Your answer should be compact. -5337.1. What is the average Emissions (in thousand metric tons of CO2 equivalent) of 1990 per country?
Give a very brief answer. 2457.58. What is the average Emissions (in thousand metric tons of CO2 equivalent) of 2000 per country?
Provide a succinct answer. 2425.2. What is the average Emissions (in thousand metric tons of CO2 equivalent) of 2005 per country?
Ensure brevity in your answer.  3279.45. What is the average Emissions (in thousand metric tons of CO2 equivalent) in 2008 per country?
Your answer should be compact. 4064.43. What is the difference between the Emissions (in thousand metric tons of CO2 equivalent) of 1990 and Emissions (in thousand metric tons of CO2 equivalent) of 2000 in Spain?
Your answer should be very brief. -1891.1. What is the difference between the Emissions (in thousand metric tons of CO2 equivalent) in 1990 and Emissions (in thousand metric tons of CO2 equivalent) in 2005 in Spain?
Your answer should be compact. -2909.1. What is the difference between the Emissions (in thousand metric tons of CO2 equivalent) of 1990 and Emissions (in thousand metric tons of CO2 equivalent) of 2008 in Spain?
Provide a succinct answer. -5201.8. What is the difference between the Emissions (in thousand metric tons of CO2 equivalent) in 2000 and Emissions (in thousand metric tons of CO2 equivalent) in 2005 in Spain?
Provide a succinct answer. -1018. What is the difference between the Emissions (in thousand metric tons of CO2 equivalent) in 2000 and Emissions (in thousand metric tons of CO2 equivalent) in 2008 in Spain?
Offer a terse response. -3310.7. What is the difference between the Emissions (in thousand metric tons of CO2 equivalent) in 2005 and Emissions (in thousand metric tons of CO2 equivalent) in 2008 in Spain?
Give a very brief answer. -2292.7. What is the difference between the Emissions (in thousand metric tons of CO2 equivalent) in 1990 and Emissions (in thousand metric tons of CO2 equivalent) in 2000 in Sweden?
Provide a succinct answer. -596.7. What is the difference between the Emissions (in thousand metric tons of CO2 equivalent) of 1990 and Emissions (in thousand metric tons of CO2 equivalent) of 2005 in Sweden?
Offer a terse response. -1179.8. What is the difference between the Emissions (in thousand metric tons of CO2 equivalent) in 1990 and Emissions (in thousand metric tons of CO2 equivalent) in 2008 in Sweden?
Your response must be concise. -1452.3. What is the difference between the Emissions (in thousand metric tons of CO2 equivalent) in 2000 and Emissions (in thousand metric tons of CO2 equivalent) in 2005 in Sweden?
Make the answer very short. -583.1. What is the difference between the Emissions (in thousand metric tons of CO2 equivalent) in 2000 and Emissions (in thousand metric tons of CO2 equivalent) in 2008 in Sweden?
Offer a terse response. -855.6. What is the difference between the Emissions (in thousand metric tons of CO2 equivalent) in 2005 and Emissions (in thousand metric tons of CO2 equivalent) in 2008 in Sweden?
Your answer should be compact. -272.5. What is the difference between the Emissions (in thousand metric tons of CO2 equivalent) of 1990 and Emissions (in thousand metric tons of CO2 equivalent) of 2000 in Switzerland?
Your response must be concise. -336.6. What is the difference between the Emissions (in thousand metric tons of CO2 equivalent) in 1990 and Emissions (in thousand metric tons of CO2 equivalent) in 2005 in Switzerland?
Ensure brevity in your answer.  -1122.4. What is the difference between the Emissions (in thousand metric tons of CO2 equivalent) of 1990 and Emissions (in thousand metric tons of CO2 equivalent) of 2008 in Switzerland?
Keep it short and to the point. -1731.5. What is the difference between the Emissions (in thousand metric tons of CO2 equivalent) of 2000 and Emissions (in thousand metric tons of CO2 equivalent) of 2005 in Switzerland?
Provide a short and direct response. -785.8. What is the difference between the Emissions (in thousand metric tons of CO2 equivalent) in 2000 and Emissions (in thousand metric tons of CO2 equivalent) in 2008 in Switzerland?
Make the answer very short. -1394.9. What is the difference between the Emissions (in thousand metric tons of CO2 equivalent) of 2005 and Emissions (in thousand metric tons of CO2 equivalent) of 2008 in Switzerland?
Your answer should be very brief. -609.1. What is the difference between the Emissions (in thousand metric tons of CO2 equivalent) in 1990 and Emissions (in thousand metric tons of CO2 equivalent) in 2000 in Tajikistan?
Keep it short and to the point. 2008.1. What is the difference between the Emissions (in thousand metric tons of CO2 equivalent) in 1990 and Emissions (in thousand metric tons of CO2 equivalent) in 2005 in Tajikistan?
Provide a short and direct response. 2423.1. What is the difference between the Emissions (in thousand metric tons of CO2 equivalent) in 1990 and Emissions (in thousand metric tons of CO2 equivalent) in 2008 in Tajikistan?
Make the answer very short. 2457.8. What is the difference between the Emissions (in thousand metric tons of CO2 equivalent) in 2000 and Emissions (in thousand metric tons of CO2 equivalent) in 2005 in Tajikistan?
Provide a short and direct response. 415. What is the difference between the Emissions (in thousand metric tons of CO2 equivalent) in 2000 and Emissions (in thousand metric tons of CO2 equivalent) in 2008 in Tajikistan?
Keep it short and to the point. 449.7. What is the difference between the Emissions (in thousand metric tons of CO2 equivalent) in 2005 and Emissions (in thousand metric tons of CO2 equivalent) in 2008 in Tajikistan?
Your answer should be very brief. 34.7. What is the difference between the Emissions (in thousand metric tons of CO2 equivalent) in 1990 and Emissions (in thousand metric tons of CO2 equivalent) in 2000 in Thailand?
Offer a terse response. 976.4. What is the difference between the Emissions (in thousand metric tons of CO2 equivalent) in 1990 and Emissions (in thousand metric tons of CO2 equivalent) in 2005 in Thailand?
Offer a terse response. 325.6. What is the difference between the Emissions (in thousand metric tons of CO2 equivalent) of 1990 and Emissions (in thousand metric tons of CO2 equivalent) of 2008 in Thailand?
Your answer should be very brief. 155. What is the difference between the Emissions (in thousand metric tons of CO2 equivalent) in 2000 and Emissions (in thousand metric tons of CO2 equivalent) in 2005 in Thailand?
Your answer should be compact. -650.8. What is the difference between the Emissions (in thousand metric tons of CO2 equivalent) of 2000 and Emissions (in thousand metric tons of CO2 equivalent) of 2008 in Thailand?
Provide a short and direct response. -821.4. What is the difference between the Emissions (in thousand metric tons of CO2 equivalent) of 2005 and Emissions (in thousand metric tons of CO2 equivalent) of 2008 in Thailand?
Your response must be concise. -170.6. What is the difference between the Emissions (in thousand metric tons of CO2 equivalent) of 1990 and Emissions (in thousand metric tons of CO2 equivalent) of 2000 in Turkey?
Provide a short and direct response. 34.2. What is the difference between the Emissions (in thousand metric tons of CO2 equivalent) of 1990 and Emissions (in thousand metric tons of CO2 equivalent) of 2005 in Turkey?
Provide a succinct answer. -2468.6. What is the difference between the Emissions (in thousand metric tons of CO2 equivalent) in 1990 and Emissions (in thousand metric tons of CO2 equivalent) in 2008 in Turkey?
Ensure brevity in your answer.  -3868.3. What is the difference between the Emissions (in thousand metric tons of CO2 equivalent) of 2000 and Emissions (in thousand metric tons of CO2 equivalent) of 2005 in Turkey?
Keep it short and to the point. -2502.8. What is the difference between the Emissions (in thousand metric tons of CO2 equivalent) of 2000 and Emissions (in thousand metric tons of CO2 equivalent) of 2008 in Turkey?
Your answer should be compact. -3902.5. What is the difference between the Emissions (in thousand metric tons of CO2 equivalent) in 2005 and Emissions (in thousand metric tons of CO2 equivalent) in 2008 in Turkey?
Offer a terse response. -1399.7. What is the ratio of the Emissions (in thousand metric tons of CO2 equivalent) in 1990 in Spain to that in Sweden?
Make the answer very short. 6.92. What is the ratio of the Emissions (in thousand metric tons of CO2 equivalent) in 2000 in Spain to that in Sweden?
Make the answer very short. 5.41. What is the ratio of the Emissions (in thousand metric tons of CO2 equivalent) of 2005 in Spain to that in Sweden?
Your answer should be compact. 4.38. What is the ratio of the Emissions (in thousand metric tons of CO2 equivalent) in 2008 in Spain to that in Sweden?
Your answer should be very brief. 4.85. What is the ratio of the Emissions (in thousand metric tons of CO2 equivalent) in 1990 in Spain to that in Switzerland?
Your answer should be very brief. 6.81. What is the ratio of the Emissions (in thousand metric tons of CO2 equivalent) in 2000 in Spain to that in Switzerland?
Your response must be concise. 6.49. What is the ratio of the Emissions (in thousand metric tons of CO2 equivalent) of 2005 in Spain to that in Switzerland?
Keep it short and to the point. 4.47. What is the ratio of the Emissions (in thousand metric tons of CO2 equivalent) in 2008 in Spain to that in Switzerland?
Offer a very short reply. 4.31. What is the ratio of the Emissions (in thousand metric tons of CO2 equivalent) of 1990 in Spain to that in Tajikistan?
Your response must be concise. 2.19. What is the ratio of the Emissions (in thousand metric tons of CO2 equivalent) of 2000 in Spain to that in Tajikistan?
Offer a very short reply. 10.07. What is the ratio of the Emissions (in thousand metric tons of CO2 equivalent) in 2005 in Spain to that in Tajikistan?
Give a very brief answer. 23.64. What is the ratio of the Emissions (in thousand metric tons of CO2 equivalent) of 2008 in Spain to that in Tajikistan?
Provide a short and direct response. 32.58. What is the ratio of the Emissions (in thousand metric tons of CO2 equivalent) in 1990 in Spain to that in Thailand?
Your response must be concise. 4.3. What is the ratio of the Emissions (in thousand metric tons of CO2 equivalent) in 2000 in Spain to that in Thailand?
Provide a succinct answer. 17.74. What is the ratio of the Emissions (in thousand metric tons of CO2 equivalent) of 2005 in Spain to that in Thailand?
Your answer should be compact. 8.2. What is the ratio of the Emissions (in thousand metric tons of CO2 equivalent) of 2008 in Spain to that in Thailand?
Your answer should be compact. 8.9. What is the ratio of the Emissions (in thousand metric tons of CO2 equivalent) in 1990 in Spain to that in Turkey?
Your response must be concise. 2.39. What is the ratio of the Emissions (in thousand metric tons of CO2 equivalent) of 2000 in Spain to that in Turkey?
Provide a succinct answer. 3.17. What is the ratio of the Emissions (in thousand metric tons of CO2 equivalent) in 2005 in Spain to that in Turkey?
Your answer should be very brief. 1.8. What is the ratio of the Emissions (in thousand metric tons of CO2 equivalent) of 2008 in Spain to that in Turkey?
Your answer should be compact. 1.76. What is the ratio of the Emissions (in thousand metric tons of CO2 equivalent) of 1990 in Sweden to that in Switzerland?
Offer a very short reply. 0.98. What is the ratio of the Emissions (in thousand metric tons of CO2 equivalent) of 2000 in Sweden to that in Switzerland?
Your response must be concise. 1.2. What is the ratio of the Emissions (in thousand metric tons of CO2 equivalent) of 2005 in Sweden to that in Switzerland?
Provide a succinct answer. 1.02. What is the ratio of the Emissions (in thousand metric tons of CO2 equivalent) in 2008 in Sweden to that in Switzerland?
Your answer should be compact. 0.89. What is the ratio of the Emissions (in thousand metric tons of CO2 equivalent) of 1990 in Sweden to that in Tajikistan?
Your answer should be compact. 0.32. What is the ratio of the Emissions (in thousand metric tons of CO2 equivalent) of 2000 in Sweden to that in Tajikistan?
Your answer should be compact. 1.86. What is the ratio of the Emissions (in thousand metric tons of CO2 equivalent) of 2005 in Sweden to that in Tajikistan?
Ensure brevity in your answer.  5.4. What is the ratio of the Emissions (in thousand metric tons of CO2 equivalent) of 2008 in Sweden to that in Tajikistan?
Offer a terse response. 6.72. What is the ratio of the Emissions (in thousand metric tons of CO2 equivalent) of 1990 in Sweden to that in Thailand?
Your answer should be compact. 0.62. What is the ratio of the Emissions (in thousand metric tons of CO2 equivalent) of 2000 in Sweden to that in Thailand?
Offer a very short reply. 3.28. What is the ratio of the Emissions (in thousand metric tons of CO2 equivalent) of 2005 in Sweden to that in Thailand?
Offer a terse response. 1.87. What is the ratio of the Emissions (in thousand metric tons of CO2 equivalent) of 2008 in Sweden to that in Thailand?
Make the answer very short. 1.84. What is the ratio of the Emissions (in thousand metric tons of CO2 equivalent) in 1990 in Sweden to that in Turkey?
Give a very brief answer. 0.35. What is the ratio of the Emissions (in thousand metric tons of CO2 equivalent) in 2000 in Sweden to that in Turkey?
Give a very brief answer. 0.59. What is the ratio of the Emissions (in thousand metric tons of CO2 equivalent) of 2005 in Sweden to that in Turkey?
Your answer should be very brief. 0.41. What is the ratio of the Emissions (in thousand metric tons of CO2 equivalent) of 2008 in Sweden to that in Turkey?
Offer a terse response. 0.36. What is the ratio of the Emissions (in thousand metric tons of CO2 equivalent) of 1990 in Switzerland to that in Tajikistan?
Offer a very short reply. 0.32. What is the ratio of the Emissions (in thousand metric tons of CO2 equivalent) of 2000 in Switzerland to that in Tajikistan?
Provide a succinct answer. 1.55. What is the ratio of the Emissions (in thousand metric tons of CO2 equivalent) of 2005 in Switzerland to that in Tajikistan?
Ensure brevity in your answer.  5.29. What is the ratio of the Emissions (in thousand metric tons of CO2 equivalent) in 2008 in Switzerland to that in Tajikistan?
Offer a very short reply. 7.56. What is the ratio of the Emissions (in thousand metric tons of CO2 equivalent) of 1990 in Switzerland to that in Thailand?
Provide a succinct answer. 0.63. What is the ratio of the Emissions (in thousand metric tons of CO2 equivalent) of 2000 in Switzerland to that in Thailand?
Ensure brevity in your answer.  2.73. What is the ratio of the Emissions (in thousand metric tons of CO2 equivalent) of 2005 in Switzerland to that in Thailand?
Give a very brief answer. 1.83. What is the ratio of the Emissions (in thousand metric tons of CO2 equivalent) of 2008 in Switzerland to that in Thailand?
Keep it short and to the point. 2.07. What is the ratio of the Emissions (in thousand metric tons of CO2 equivalent) in 1990 in Switzerland to that in Turkey?
Your answer should be very brief. 0.35. What is the ratio of the Emissions (in thousand metric tons of CO2 equivalent) of 2000 in Switzerland to that in Turkey?
Provide a short and direct response. 0.49. What is the ratio of the Emissions (in thousand metric tons of CO2 equivalent) of 2005 in Switzerland to that in Turkey?
Give a very brief answer. 0.4. What is the ratio of the Emissions (in thousand metric tons of CO2 equivalent) in 2008 in Switzerland to that in Turkey?
Ensure brevity in your answer.  0.41. What is the ratio of the Emissions (in thousand metric tons of CO2 equivalent) of 1990 in Tajikistan to that in Thailand?
Offer a terse response. 1.96. What is the ratio of the Emissions (in thousand metric tons of CO2 equivalent) in 2000 in Tajikistan to that in Thailand?
Ensure brevity in your answer.  1.76. What is the ratio of the Emissions (in thousand metric tons of CO2 equivalent) in 2005 in Tajikistan to that in Thailand?
Offer a very short reply. 0.35. What is the ratio of the Emissions (in thousand metric tons of CO2 equivalent) in 2008 in Tajikistan to that in Thailand?
Your answer should be compact. 0.27. What is the ratio of the Emissions (in thousand metric tons of CO2 equivalent) in 1990 in Tajikistan to that in Turkey?
Keep it short and to the point. 1.09. What is the ratio of the Emissions (in thousand metric tons of CO2 equivalent) of 2000 in Tajikistan to that in Turkey?
Give a very brief answer. 0.31. What is the ratio of the Emissions (in thousand metric tons of CO2 equivalent) of 2005 in Tajikistan to that in Turkey?
Provide a succinct answer. 0.08. What is the ratio of the Emissions (in thousand metric tons of CO2 equivalent) in 2008 in Tajikistan to that in Turkey?
Provide a short and direct response. 0.05. What is the ratio of the Emissions (in thousand metric tons of CO2 equivalent) of 1990 in Thailand to that in Turkey?
Give a very brief answer. 0.56. What is the ratio of the Emissions (in thousand metric tons of CO2 equivalent) of 2000 in Thailand to that in Turkey?
Offer a terse response. 0.18. What is the ratio of the Emissions (in thousand metric tons of CO2 equivalent) of 2005 in Thailand to that in Turkey?
Ensure brevity in your answer.  0.22. What is the ratio of the Emissions (in thousand metric tons of CO2 equivalent) of 2008 in Thailand to that in Turkey?
Make the answer very short. 0.2. What is the difference between the highest and the second highest Emissions (in thousand metric tons of CO2 equivalent) in 1990?
Provide a short and direct response. 3339.9. What is the difference between the highest and the second highest Emissions (in thousand metric tons of CO2 equivalent) of 2000?
Your response must be concise. 5498.6. What is the difference between the highest and the second highest Emissions (in thousand metric tons of CO2 equivalent) in 2005?
Keep it short and to the point. 4013.8. What is the difference between the highest and the second highest Emissions (in thousand metric tons of CO2 equivalent) in 2008?
Offer a terse response. 4906.8. What is the difference between the highest and the lowest Emissions (in thousand metric tons of CO2 equivalent) of 1990?
Offer a very short reply. 5257.4. What is the difference between the highest and the lowest Emissions (in thousand metric tons of CO2 equivalent) of 2000?
Provide a short and direct response. 7584. What is the difference between the highest and the lowest Emissions (in thousand metric tons of CO2 equivalent) of 2005?
Offer a very short reply. 8672.1. What is the difference between the highest and the lowest Emissions (in thousand metric tons of CO2 equivalent) of 2008?
Your answer should be compact. 1.10e+04. 